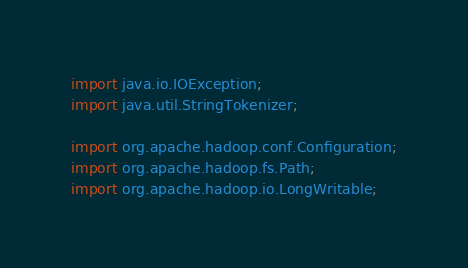<code> <loc_0><loc_0><loc_500><loc_500><_Java_>import java.io.IOException;
import java.util.StringTokenizer;

import org.apache.hadoop.conf.Configuration;
import org.apache.hadoop.fs.Path;
import org.apache.hadoop.io.LongWritable;</code> 